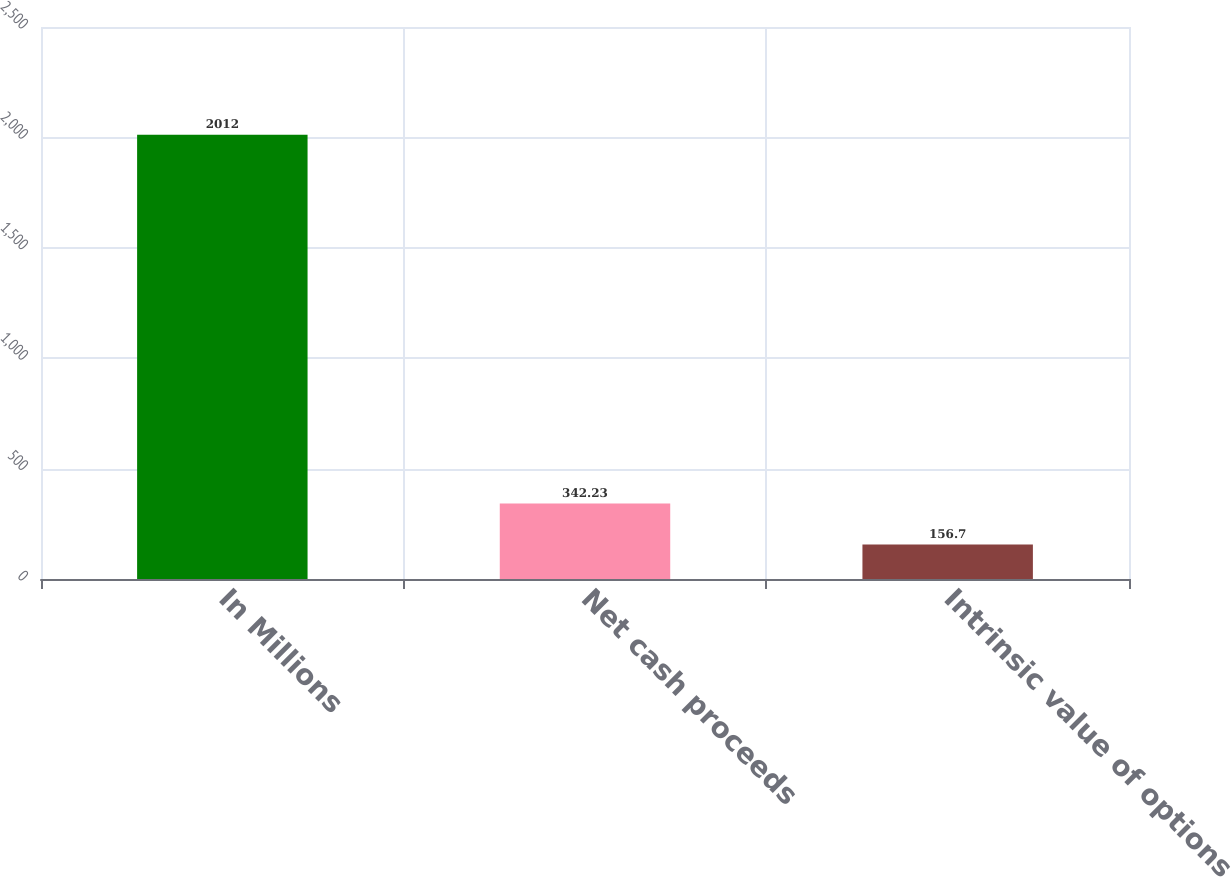<chart> <loc_0><loc_0><loc_500><loc_500><bar_chart><fcel>In Millions<fcel>Net cash proceeds<fcel>Intrinsic value of options<nl><fcel>2012<fcel>342.23<fcel>156.7<nl></chart> 